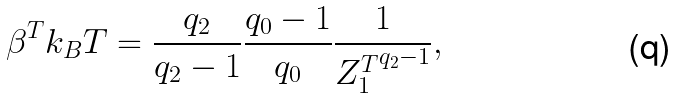<formula> <loc_0><loc_0><loc_500><loc_500>\beta ^ { T } k _ { B } T = \frac { q _ { 2 } } { q _ { 2 } - 1 } \frac { q _ { 0 } - 1 } { q _ { 0 } } \frac { 1 } { { Z ^ { T } _ { 1 } } ^ { q _ { 2 } - 1 } } ,</formula> 